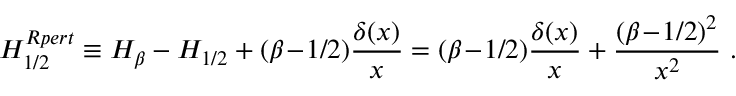<formula> <loc_0><loc_0><loc_500><loc_500>H _ { 1 / 2 } ^ { R p e r t } \equiv H _ { \beta } - H _ { 1 / 2 } + ( \beta \, - \, 1 / 2 ) { \frac { \delta ( x ) } { x } } = ( \beta \, - \, 1 / 2 ) { \frac { \delta ( x ) } { x } } + { \frac { ( \beta \, - \, 1 / 2 ) ^ { 2 } } { x ^ { 2 } } } .</formula> 